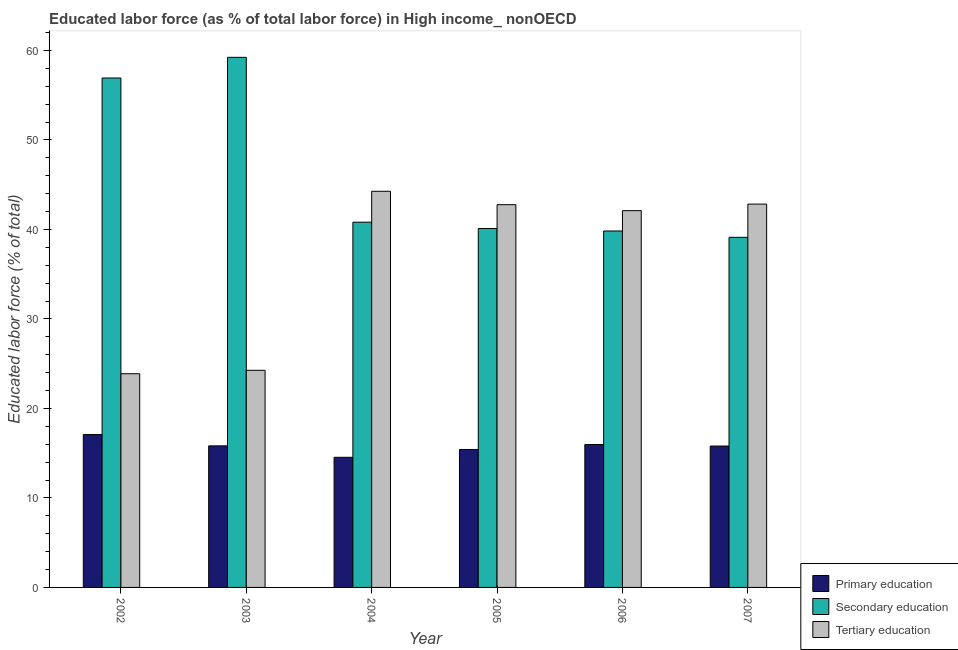How many different coloured bars are there?
Make the answer very short. 3. Are the number of bars per tick equal to the number of legend labels?
Give a very brief answer. Yes. How many bars are there on the 1st tick from the left?
Give a very brief answer. 3. How many bars are there on the 4th tick from the right?
Ensure brevity in your answer.  3. In how many cases, is the number of bars for a given year not equal to the number of legend labels?
Keep it short and to the point. 0. What is the percentage of labor force who received primary education in 2005?
Provide a succinct answer. 15.41. Across all years, what is the maximum percentage of labor force who received tertiary education?
Provide a succinct answer. 44.27. Across all years, what is the minimum percentage of labor force who received primary education?
Make the answer very short. 14.54. In which year was the percentage of labor force who received secondary education maximum?
Ensure brevity in your answer.  2003. What is the total percentage of labor force who received primary education in the graph?
Provide a succinct answer. 94.63. What is the difference between the percentage of labor force who received primary education in 2002 and that in 2005?
Offer a very short reply. 1.67. What is the difference between the percentage of labor force who received primary education in 2007 and the percentage of labor force who received tertiary education in 2004?
Make the answer very short. 1.26. What is the average percentage of labor force who received primary education per year?
Your response must be concise. 15.77. In the year 2002, what is the difference between the percentage of labor force who received secondary education and percentage of labor force who received tertiary education?
Ensure brevity in your answer.  0. What is the ratio of the percentage of labor force who received secondary education in 2005 to that in 2007?
Your answer should be very brief. 1.03. Is the percentage of labor force who received secondary education in 2004 less than that in 2006?
Provide a succinct answer. No. Is the difference between the percentage of labor force who received tertiary education in 2002 and 2006 greater than the difference between the percentage of labor force who received secondary education in 2002 and 2006?
Provide a short and direct response. No. What is the difference between the highest and the second highest percentage of labor force who received tertiary education?
Offer a terse response. 1.43. What is the difference between the highest and the lowest percentage of labor force who received primary education?
Your answer should be compact. 2.54. Is the sum of the percentage of labor force who received primary education in 2002 and 2004 greater than the maximum percentage of labor force who received secondary education across all years?
Give a very brief answer. Yes. What does the 1st bar from the left in 2007 represents?
Provide a succinct answer. Primary education. What does the 3rd bar from the right in 2004 represents?
Give a very brief answer. Primary education. Is it the case that in every year, the sum of the percentage of labor force who received primary education and percentage of labor force who received secondary education is greater than the percentage of labor force who received tertiary education?
Make the answer very short. Yes. How many years are there in the graph?
Give a very brief answer. 6. Are the values on the major ticks of Y-axis written in scientific E-notation?
Keep it short and to the point. No. Where does the legend appear in the graph?
Offer a terse response. Bottom right. How are the legend labels stacked?
Provide a short and direct response. Vertical. What is the title of the graph?
Your answer should be compact. Educated labor force (as % of total labor force) in High income_ nonOECD. What is the label or title of the Y-axis?
Offer a terse response. Educated labor force (% of total). What is the Educated labor force (% of total) of Primary education in 2002?
Make the answer very short. 17.08. What is the Educated labor force (% of total) of Secondary education in 2002?
Provide a short and direct response. 56.93. What is the Educated labor force (% of total) in Tertiary education in 2002?
Your answer should be compact. 23.88. What is the Educated labor force (% of total) in Primary education in 2003?
Provide a succinct answer. 15.82. What is the Educated labor force (% of total) in Secondary education in 2003?
Give a very brief answer. 59.23. What is the Educated labor force (% of total) in Tertiary education in 2003?
Keep it short and to the point. 24.26. What is the Educated labor force (% of total) in Primary education in 2004?
Your answer should be compact. 14.54. What is the Educated labor force (% of total) in Secondary education in 2004?
Give a very brief answer. 40.81. What is the Educated labor force (% of total) in Tertiary education in 2004?
Give a very brief answer. 44.27. What is the Educated labor force (% of total) of Primary education in 2005?
Provide a succinct answer. 15.41. What is the Educated labor force (% of total) of Secondary education in 2005?
Offer a terse response. 40.1. What is the Educated labor force (% of total) of Tertiary education in 2005?
Your response must be concise. 42.77. What is the Educated labor force (% of total) in Primary education in 2006?
Keep it short and to the point. 15.97. What is the Educated labor force (% of total) in Secondary education in 2006?
Your answer should be very brief. 39.83. What is the Educated labor force (% of total) of Tertiary education in 2006?
Keep it short and to the point. 42.1. What is the Educated labor force (% of total) of Primary education in 2007?
Give a very brief answer. 15.8. What is the Educated labor force (% of total) in Secondary education in 2007?
Provide a short and direct response. 39.12. What is the Educated labor force (% of total) of Tertiary education in 2007?
Ensure brevity in your answer.  42.83. Across all years, what is the maximum Educated labor force (% of total) in Primary education?
Ensure brevity in your answer.  17.08. Across all years, what is the maximum Educated labor force (% of total) of Secondary education?
Give a very brief answer. 59.23. Across all years, what is the maximum Educated labor force (% of total) in Tertiary education?
Provide a short and direct response. 44.27. Across all years, what is the minimum Educated labor force (% of total) of Primary education?
Offer a very short reply. 14.54. Across all years, what is the minimum Educated labor force (% of total) of Secondary education?
Make the answer very short. 39.12. Across all years, what is the minimum Educated labor force (% of total) of Tertiary education?
Give a very brief answer. 23.88. What is the total Educated labor force (% of total) in Primary education in the graph?
Provide a succinct answer. 94.63. What is the total Educated labor force (% of total) in Secondary education in the graph?
Make the answer very short. 276.03. What is the total Educated labor force (% of total) in Tertiary education in the graph?
Provide a succinct answer. 220.11. What is the difference between the Educated labor force (% of total) in Primary education in 2002 and that in 2003?
Your response must be concise. 1.27. What is the difference between the Educated labor force (% of total) in Secondary education in 2002 and that in 2003?
Ensure brevity in your answer.  -2.31. What is the difference between the Educated labor force (% of total) in Tertiary education in 2002 and that in 2003?
Offer a very short reply. -0.38. What is the difference between the Educated labor force (% of total) in Primary education in 2002 and that in 2004?
Keep it short and to the point. 2.54. What is the difference between the Educated labor force (% of total) of Secondary education in 2002 and that in 2004?
Offer a terse response. 16.11. What is the difference between the Educated labor force (% of total) in Tertiary education in 2002 and that in 2004?
Your response must be concise. -20.39. What is the difference between the Educated labor force (% of total) in Primary education in 2002 and that in 2005?
Your answer should be very brief. 1.67. What is the difference between the Educated labor force (% of total) of Secondary education in 2002 and that in 2005?
Your answer should be compact. 16.82. What is the difference between the Educated labor force (% of total) in Tertiary education in 2002 and that in 2005?
Your answer should be compact. -18.89. What is the difference between the Educated labor force (% of total) of Primary education in 2002 and that in 2006?
Offer a very short reply. 1.11. What is the difference between the Educated labor force (% of total) in Secondary education in 2002 and that in 2006?
Give a very brief answer. 17.1. What is the difference between the Educated labor force (% of total) of Tertiary education in 2002 and that in 2006?
Provide a short and direct response. -18.22. What is the difference between the Educated labor force (% of total) of Primary education in 2002 and that in 2007?
Your response must be concise. 1.28. What is the difference between the Educated labor force (% of total) of Secondary education in 2002 and that in 2007?
Your response must be concise. 17.8. What is the difference between the Educated labor force (% of total) in Tertiary education in 2002 and that in 2007?
Provide a succinct answer. -18.95. What is the difference between the Educated labor force (% of total) of Primary education in 2003 and that in 2004?
Offer a terse response. 1.28. What is the difference between the Educated labor force (% of total) in Secondary education in 2003 and that in 2004?
Provide a short and direct response. 18.42. What is the difference between the Educated labor force (% of total) in Tertiary education in 2003 and that in 2004?
Make the answer very short. -20.01. What is the difference between the Educated labor force (% of total) of Primary education in 2003 and that in 2005?
Provide a succinct answer. 0.4. What is the difference between the Educated labor force (% of total) of Secondary education in 2003 and that in 2005?
Keep it short and to the point. 19.13. What is the difference between the Educated labor force (% of total) in Tertiary education in 2003 and that in 2005?
Give a very brief answer. -18.51. What is the difference between the Educated labor force (% of total) in Primary education in 2003 and that in 2006?
Your answer should be very brief. -0.15. What is the difference between the Educated labor force (% of total) in Secondary education in 2003 and that in 2006?
Provide a succinct answer. 19.4. What is the difference between the Educated labor force (% of total) of Tertiary education in 2003 and that in 2006?
Your answer should be very brief. -17.84. What is the difference between the Educated labor force (% of total) in Primary education in 2003 and that in 2007?
Your answer should be very brief. 0.02. What is the difference between the Educated labor force (% of total) of Secondary education in 2003 and that in 2007?
Offer a terse response. 20.11. What is the difference between the Educated labor force (% of total) of Tertiary education in 2003 and that in 2007?
Your answer should be compact. -18.57. What is the difference between the Educated labor force (% of total) in Primary education in 2004 and that in 2005?
Give a very brief answer. -0.87. What is the difference between the Educated labor force (% of total) in Secondary education in 2004 and that in 2005?
Keep it short and to the point. 0.71. What is the difference between the Educated labor force (% of total) of Tertiary education in 2004 and that in 2005?
Your answer should be compact. 1.5. What is the difference between the Educated labor force (% of total) in Primary education in 2004 and that in 2006?
Ensure brevity in your answer.  -1.43. What is the difference between the Educated labor force (% of total) in Secondary education in 2004 and that in 2006?
Keep it short and to the point. 0.98. What is the difference between the Educated labor force (% of total) of Tertiary education in 2004 and that in 2006?
Offer a very short reply. 2.17. What is the difference between the Educated labor force (% of total) of Primary education in 2004 and that in 2007?
Offer a very short reply. -1.26. What is the difference between the Educated labor force (% of total) in Secondary education in 2004 and that in 2007?
Offer a very short reply. 1.69. What is the difference between the Educated labor force (% of total) of Tertiary education in 2004 and that in 2007?
Give a very brief answer. 1.43. What is the difference between the Educated labor force (% of total) of Primary education in 2005 and that in 2006?
Your answer should be very brief. -0.56. What is the difference between the Educated labor force (% of total) in Secondary education in 2005 and that in 2006?
Offer a terse response. 0.27. What is the difference between the Educated labor force (% of total) of Tertiary education in 2005 and that in 2006?
Give a very brief answer. 0.67. What is the difference between the Educated labor force (% of total) in Primary education in 2005 and that in 2007?
Offer a very short reply. -0.39. What is the difference between the Educated labor force (% of total) in Secondary education in 2005 and that in 2007?
Ensure brevity in your answer.  0.98. What is the difference between the Educated labor force (% of total) in Tertiary education in 2005 and that in 2007?
Your answer should be very brief. -0.06. What is the difference between the Educated labor force (% of total) in Primary education in 2006 and that in 2007?
Make the answer very short. 0.17. What is the difference between the Educated labor force (% of total) of Secondary education in 2006 and that in 2007?
Your answer should be very brief. 0.71. What is the difference between the Educated labor force (% of total) of Tertiary education in 2006 and that in 2007?
Your response must be concise. -0.73. What is the difference between the Educated labor force (% of total) of Primary education in 2002 and the Educated labor force (% of total) of Secondary education in 2003?
Your response must be concise. -42.15. What is the difference between the Educated labor force (% of total) in Primary education in 2002 and the Educated labor force (% of total) in Tertiary education in 2003?
Provide a succinct answer. -7.18. What is the difference between the Educated labor force (% of total) of Secondary education in 2002 and the Educated labor force (% of total) of Tertiary education in 2003?
Your response must be concise. 32.67. What is the difference between the Educated labor force (% of total) of Primary education in 2002 and the Educated labor force (% of total) of Secondary education in 2004?
Your answer should be very brief. -23.73. What is the difference between the Educated labor force (% of total) of Primary education in 2002 and the Educated labor force (% of total) of Tertiary education in 2004?
Give a very brief answer. -27.18. What is the difference between the Educated labor force (% of total) in Secondary education in 2002 and the Educated labor force (% of total) in Tertiary education in 2004?
Your response must be concise. 12.66. What is the difference between the Educated labor force (% of total) in Primary education in 2002 and the Educated labor force (% of total) in Secondary education in 2005?
Ensure brevity in your answer.  -23.02. What is the difference between the Educated labor force (% of total) of Primary education in 2002 and the Educated labor force (% of total) of Tertiary education in 2005?
Your answer should be very brief. -25.69. What is the difference between the Educated labor force (% of total) of Secondary education in 2002 and the Educated labor force (% of total) of Tertiary education in 2005?
Make the answer very short. 14.16. What is the difference between the Educated labor force (% of total) of Primary education in 2002 and the Educated labor force (% of total) of Secondary education in 2006?
Provide a short and direct response. -22.75. What is the difference between the Educated labor force (% of total) in Primary education in 2002 and the Educated labor force (% of total) in Tertiary education in 2006?
Provide a succinct answer. -25.02. What is the difference between the Educated labor force (% of total) of Secondary education in 2002 and the Educated labor force (% of total) of Tertiary education in 2006?
Make the answer very short. 14.82. What is the difference between the Educated labor force (% of total) in Primary education in 2002 and the Educated labor force (% of total) in Secondary education in 2007?
Your answer should be compact. -22.04. What is the difference between the Educated labor force (% of total) of Primary education in 2002 and the Educated labor force (% of total) of Tertiary education in 2007?
Give a very brief answer. -25.75. What is the difference between the Educated labor force (% of total) of Secondary education in 2002 and the Educated labor force (% of total) of Tertiary education in 2007?
Offer a terse response. 14.09. What is the difference between the Educated labor force (% of total) in Primary education in 2003 and the Educated labor force (% of total) in Secondary education in 2004?
Your answer should be very brief. -25. What is the difference between the Educated labor force (% of total) of Primary education in 2003 and the Educated labor force (% of total) of Tertiary education in 2004?
Ensure brevity in your answer.  -28.45. What is the difference between the Educated labor force (% of total) of Secondary education in 2003 and the Educated labor force (% of total) of Tertiary education in 2004?
Your answer should be very brief. 14.97. What is the difference between the Educated labor force (% of total) of Primary education in 2003 and the Educated labor force (% of total) of Secondary education in 2005?
Keep it short and to the point. -24.28. What is the difference between the Educated labor force (% of total) in Primary education in 2003 and the Educated labor force (% of total) in Tertiary education in 2005?
Your answer should be very brief. -26.95. What is the difference between the Educated labor force (% of total) in Secondary education in 2003 and the Educated labor force (% of total) in Tertiary education in 2005?
Offer a very short reply. 16.47. What is the difference between the Educated labor force (% of total) of Primary education in 2003 and the Educated labor force (% of total) of Secondary education in 2006?
Provide a succinct answer. -24.01. What is the difference between the Educated labor force (% of total) in Primary education in 2003 and the Educated labor force (% of total) in Tertiary education in 2006?
Your response must be concise. -26.28. What is the difference between the Educated labor force (% of total) in Secondary education in 2003 and the Educated labor force (% of total) in Tertiary education in 2006?
Offer a very short reply. 17.13. What is the difference between the Educated labor force (% of total) in Primary education in 2003 and the Educated labor force (% of total) in Secondary education in 2007?
Give a very brief answer. -23.3. What is the difference between the Educated labor force (% of total) in Primary education in 2003 and the Educated labor force (% of total) in Tertiary education in 2007?
Your answer should be compact. -27.01. What is the difference between the Educated labor force (% of total) of Secondary education in 2003 and the Educated labor force (% of total) of Tertiary education in 2007?
Give a very brief answer. 16.4. What is the difference between the Educated labor force (% of total) of Primary education in 2004 and the Educated labor force (% of total) of Secondary education in 2005?
Your answer should be very brief. -25.56. What is the difference between the Educated labor force (% of total) in Primary education in 2004 and the Educated labor force (% of total) in Tertiary education in 2005?
Your answer should be very brief. -28.23. What is the difference between the Educated labor force (% of total) of Secondary education in 2004 and the Educated labor force (% of total) of Tertiary education in 2005?
Offer a terse response. -1.96. What is the difference between the Educated labor force (% of total) of Primary education in 2004 and the Educated labor force (% of total) of Secondary education in 2006?
Keep it short and to the point. -25.29. What is the difference between the Educated labor force (% of total) of Primary education in 2004 and the Educated labor force (% of total) of Tertiary education in 2006?
Provide a succinct answer. -27.56. What is the difference between the Educated labor force (% of total) in Secondary education in 2004 and the Educated labor force (% of total) in Tertiary education in 2006?
Provide a succinct answer. -1.29. What is the difference between the Educated labor force (% of total) in Primary education in 2004 and the Educated labor force (% of total) in Secondary education in 2007?
Your response must be concise. -24.58. What is the difference between the Educated labor force (% of total) of Primary education in 2004 and the Educated labor force (% of total) of Tertiary education in 2007?
Your response must be concise. -28.29. What is the difference between the Educated labor force (% of total) in Secondary education in 2004 and the Educated labor force (% of total) in Tertiary education in 2007?
Your answer should be very brief. -2.02. What is the difference between the Educated labor force (% of total) of Primary education in 2005 and the Educated labor force (% of total) of Secondary education in 2006?
Offer a very short reply. -24.42. What is the difference between the Educated labor force (% of total) in Primary education in 2005 and the Educated labor force (% of total) in Tertiary education in 2006?
Your answer should be very brief. -26.69. What is the difference between the Educated labor force (% of total) of Secondary education in 2005 and the Educated labor force (% of total) of Tertiary education in 2006?
Provide a short and direct response. -2. What is the difference between the Educated labor force (% of total) in Primary education in 2005 and the Educated labor force (% of total) in Secondary education in 2007?
Provide a short and direct response. -23.71. What is the difference between the Educated labor force (% of total) of Primary education in 2005 and the Educated labor force (% of total) of Tertiary education in 2007?
Keep it short and to the point. -27.42. What is the difference between the Educated labor force (% of total) of Secondary education in 2005 and the Educated labor force (% of total) of Tertiary education in 2007?
Give a very brief answer. -2.73. What is the difference between the Educated labor force (% of total) of Primary education in 2006 and the Educated labor force (% of total) of Secondary education in 2007?
Offer a very short reply. -23.15. What is the difference between the Educated labor force (% of total) in Primary education in 2006 and the Educated labor force (% of total) in Tertiary education in 2007?
Keep it short and to the point. -26.86. What is the difference between the Educated labor force (% of total) in Secondary education in 2006 and the Educated labor force (% of total) in Tertiary education in 2007?
Offer a terse response. -3. What is the average Educated labor force (% of total) in Primary education per year?
Your answer should be compact. 15.77. What is the average Educated labor force (% of total) of Secondary education per year?
Keep it short and to the point. 46. What is the average Educated labor force (% of total) of Tertiary education per year?
Make the answer very short. 36.69. In the year 2002, what is the difference between the Educated labor force (% of total) in Primary education and Educated labor force (% of total) in Secondary education?
Offer a very short reply. -39.84. In the year 2002, what is the difference between the Educated labor force (% of total) of Primary education and Educated labor force (% of total) of Tertiary education?
Ensure brevity in your answer.  -6.8. In the year 2002, what is the difference between the Educated labor force (% of total) in Secondary education and Educated labor force (% of total) in Tertiary education?
Offer a very short reply. 33.05. In the year 2003, what is the difference between the Educated labor force (% of total) in Primary education and Educated labor force (% of total) in Secondary education?
Make the answer very short. -43.42. In the year 2003, what is the difference between the Educated labor force (% of total) in Primary education and Educated labor force (% of total) in Tertiary education?
Your answer should be very brief. -8.44. In the year 2003, what is the difference between the Educated labor force (% of total) of Secondary education and Educated labor force (% of total) of Tertiary education?
Your answer should be very brief. 34.98. In the year 2004, what is the difference between the Educated labor force (% of total) in Primary education and Educated labor force (% of total) in Secondary education?
Offer a very short reply. -26.27. In the year 2004, what is the difference between the Educated labor force (% of total) in Primary education and Educated labor force (% of total) in Tertiary education?
Your answer should be very brief. -29.73. In the year 2004, what is the difference between the Educated labor force (% of total) of Secondary education and Educated labor force (% of total) of Tertiary education?
Your response must be concise. -3.45. In the year 2005, what is the difference between the Educated labor force (% of total) of Primary education and Educated labor force (% of total) of Secondary education?
Your response must be concise. -24.69. In the year 2005, what is the difference between the Educated labor force (% of total) of Primary education and Educated labor force (% of total) of Tertiary education?
Your answer should be compact. -27.36. In the year 2005, what is the difference between the Educated labor force (% of total) in Secondary education and Educated labor force (% of total) in Tertiary education?
Offer a very short reply. -2.67. In the year 2006, what is the difference between the Educated labor force (% of total) in Primary education and Educated labor force (% of total) in Secondary education?
Make the answer very short. -23.86. In the year 2006, what is the difference between the Educated labor force (% of total) in Primary education and Educated labor force (% of total) in Tertiary education?
Provide a short and direct response. -26.13. In the year 2006, what is the difference between the Educated labor force (% of total) in Secondary education and Educated labor force (% of total) in Tertiary education?
Provide a succinct answer. -2.27. In the year 2007, what is the difference between the Educated labor force (% of total) of Primary education and Educated labor force (% of total) of Secondary education?
Provide a succinct answer. -23.32. In the year 2007, what is the difference between the Educated labor force (% of total) in Primary education and Educated labor force (% of total) in Tertiary education?
Give a very brief answer. -27.03. In the year 2007, what is the difference between the Educated labor force (% of total) of Secondary education and Educated labor force (% of total) of Tertiary education?
Your answer should be very brief. -3.71. What is the ratio of the Educated labor force (% of total) in Primary education in 2002 to that in 2003?
Ensure brevity in your answer.  1.08. What is the ratio of the Educated labor force (% of total) of Tertiary education in 2002 to that in 2003?
Provide a short and direct response. 0.98. What is the ratio of the Educated labor force (% of total) of Primary education in 2002 to that in 2004?
Your response must be concise. 1.17. What is the ratio of the Educated labor force (% of total) in Secondary education in 2002 to that in 2004?
Ensure brevity in your answer.  1.39. What is the ratio of the Educated labor force (% of total) of Tertiary education in 2002 to that in 2004?
Your response must be concise. 0.54. What is the ratio of the Educated labor force (% of total) of Primary education in 2002 to that in 2005?
Ensure brevity in your answer.  1.11. What is the ratio of the Educated labor force (% of total) in Secondary education in 2002 to that in 2005?
Your answer should be compact. 1.42. What is the ratio of the Educated labor force (% of total) in Tertiary education in 2002 to that in 2005?
Ensure brevity in your answer.  0.56. What is the ratio of the Educated labor force (% of total) of Primary education in 2002 to that in 2006?
Make the answer very short. 1.07. What is the ratio of the Educated labor force (% of total) in Secondary education in 2002 to that in 2006?
Keep it short and to the point. 1.43. What is the ratio of the Educated labor force (% of total) in Tertiary education in 2002 to that in 2006?
Provide a succinct answer. 0.57. What is the ratio of the Educated labor force (% of total) in Primary education in 2002 to that in 2007?
Give a very brief answer. 1.08. What is the ratio of the Educated labor force (% of total) in Secondary education in 2002 to that in 2007?
Offer a very short reply. 1.46. What is the ratio of the Educated labor force (% of total) of Tertiary education in 2002 to that in 2007?
Your answer should be compact. 0.56. What is the ratio of the Educated labor force (% of total) in Primary education in 2003 to that in 2004?
Your answer should be very brief. 1.09. What is the ratio of the Educated labor force (% of total) in Secondary education in 2003 to that in 2004?
Make the answer very short. 1.45. What is the ratio of the Educated labor force (% of total) of Tertiary education in 2003 to that in 2004?
Keep it short and to the point. 0.55. What is the ratio of the Educated labor force (% of total) of Primary education in 2003 to that in 2005?
Make the answer very short. 1.03. What is the ratio of the Educated labor force (% of total) in Secondary education in 2003 to that in 2005?
Offer a terse response. 1.48. What is the ratio of the Educated labor force (% of total) of Tertiary education in 2003 to that in 2005?
Provide a short and direct response. 0.57. What is the ratio of the Educated labor force (% of total) in Primary education in 2003 to that in 2006?
Your answer should be compact. 0.99. What is the ratio of the Educated labor force (% of total) in Secondary education in 2003 to that in 2006?
Provide a succinct answer. 1.49. What is the ratio of the Educated labor force (% of total) of Tertiary education in 2003 to that in 2006?
Your response must be concise. 0.58. What is the ratio of the Educated labor force (% of total) of Primary education in 2003 to that in 2007?
Keep it short and to the point. 1. What is the ratio of the Educated labor force (% of total) of Secondary education in 2003 to that in 2007?
Make the answer very short. 1.51. What is the ratio of the Educated labor force (% of total) of Tertiary education in 2003 to that in 2007?
Your response must be concise. 0.57. What is the ratio of the Educated labor force (% of total) of Primary education in 2004 to that in 2005?
Provide a succinct answer. 0.94. What is the ratio of the Educated labor force (% of total) of Secondary education in 2004 to that in 2005?
Make the answer very short. 1.02. What is the ratio of the Educated labor force (% of total) of Tertiary education in 2004 to that in 2005?
Make the answer very short. 1.03. What is the ratio of the Educated labor force (% of total) of Primary education in 2004 to that in 2006?
Your answer should be compact. 0.91. What is the ratio of the Educated labor force (% of total) in Secondary education in 2004 to that in 2006?
Give a very brief answer. 1.02. What is the ratio of the Educated labor force (% of total) of Tertiary education in 2004 to that in 2006?
Ensure brevity in your answer.  1.05. What is the ratio of the Educated labor force (% of total) of Primary education in 2004 to that in 2007?
Your answer should be very brief. 0.92. What is the ratio of the Educated labor force (% of total) in Secondary education in 2004 to that in 2007?
Keep it short and to the point. 1.04. What is the ratio of the Educated labor force (% of total) in Tertiary education in 2004 to that in 2007?
Your answer should be very brief. 1.03. What is the ratio of the Educated labor force (% of total) of Primary education in 2005 to that in 2006?
Your answer should be compact. 0.97. What is the ratio of the Educated labor force (% of total) of Secondary education in 2005 to that in 2006?
Offer a terse response. 1.01. What is the ratio of the Educated labor force (% of total) of Tertiary education in 2005 to that in 2006?
Your answer should be compact. 1.02. What is the ratio of the Educated labor force (% of total) in Primary education in 2005 to that in 2007?
Provide a succinct answer. 0.98. What is the ratio of the Educated labor force (% of total) of Secondary education in 2005 to that in 2007?
Offer a very short reply. 1.03. What is the ratio of the Educated labor force (% of total) in Tertiary education in 2005 to that in 2007?
Make the answer very short. 1. What is the ratio of the Educated labor force (% of total) of Primary education in 2006 to that in 2007?
Give a very brief answer. 1.01. What is the ratio of the Educated labor force (% of total) of Secondary education in 2006 to that in 2007?
Keep it short and to the point. 1.02. What is the ratio of the Educated labor force (% of total) of Tertiary education in 2006 to that in 2007?
Offer a very short reply. 0.98. What is the difference between the highest and the second highest Educated labor force (% of total) of Primary education?
Your answer should be compact. 1.11. What is the difference between the highest and the second highest Educated labor force (% of total) of Secondary education?
Provide a succinct answer. 2.31. What is the difference between the highest and the second highest Educated labor force (% of total) in Tertiary education?
Your answer should be very brief. 1.43. What is the difference between the highest and the lowest Educated labor force (% of total) in Primary education?
Your answer should be compact. 2.54. What is the difference between the highest and the lowest Educated labor force (% of total) in Secondary education?
Ensure brevity in your answer.  20.11. What is the difference between the highest and the lowest Educated labor force (% of total) of Tertiary education?
Offer a very short reply. 20.39. 